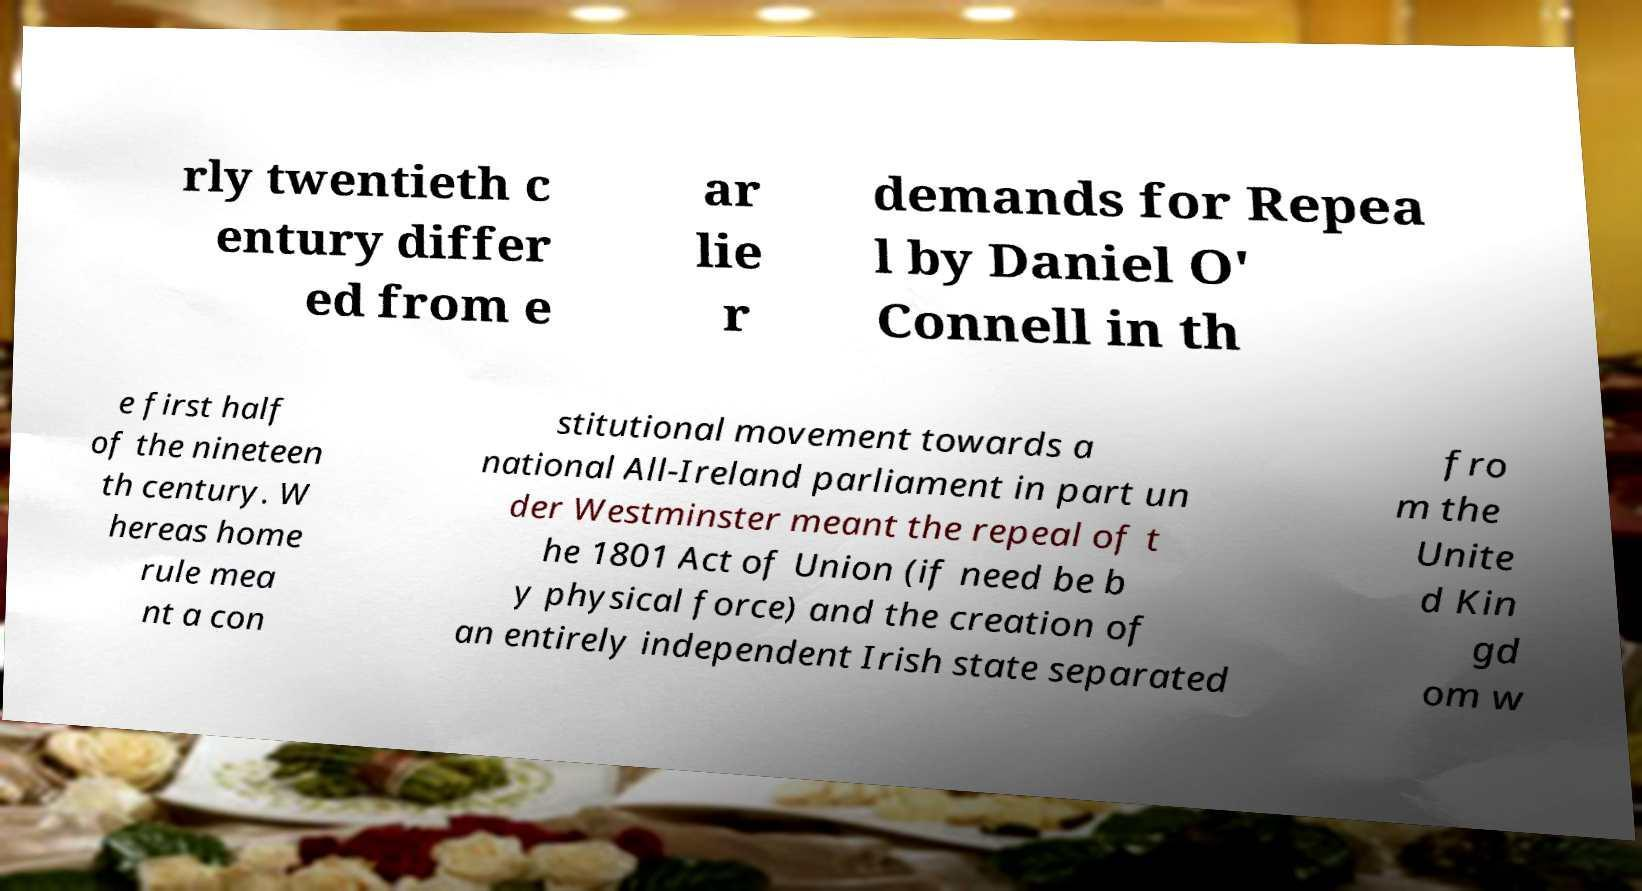Could you assist in decoding the text presented in this image and type it out clearly? rly twentieth c entury differ ed from e ar lie r demands for Repea l by Daniel O' Connell in th e first half of the nineteen th century. W hereas home rule mea nt a con stitutional movement towards a national All-Ireland parliament in part un der Westminster meant the repeal of t he 1801 Act of Union (if need be b y physical force) and the creation of an entirely independent Irish state separated fro m the Unite d Kin gd om w 